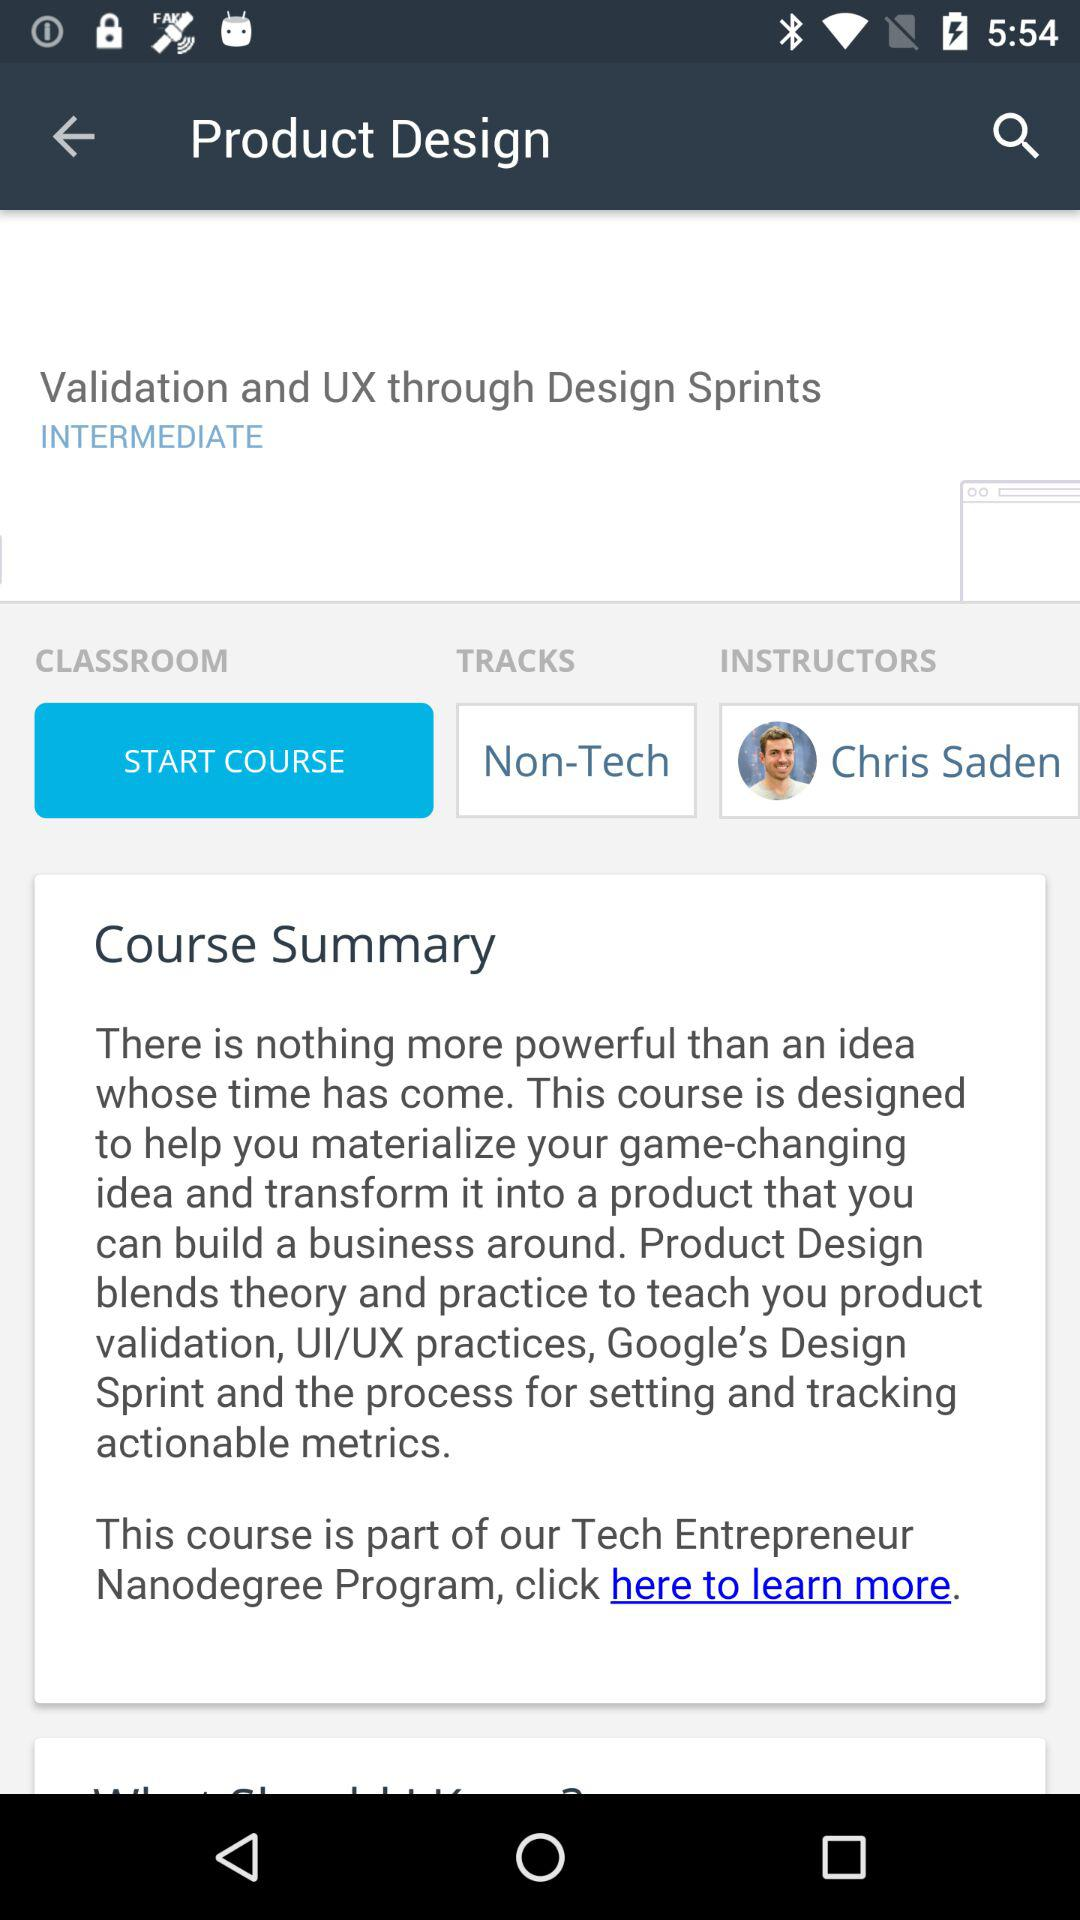What is the purpose of the "Product Design" course? The purpose of the "Product Design" course is to help you materialize your game-changing idea and transform it into a product that you can build a business around. 